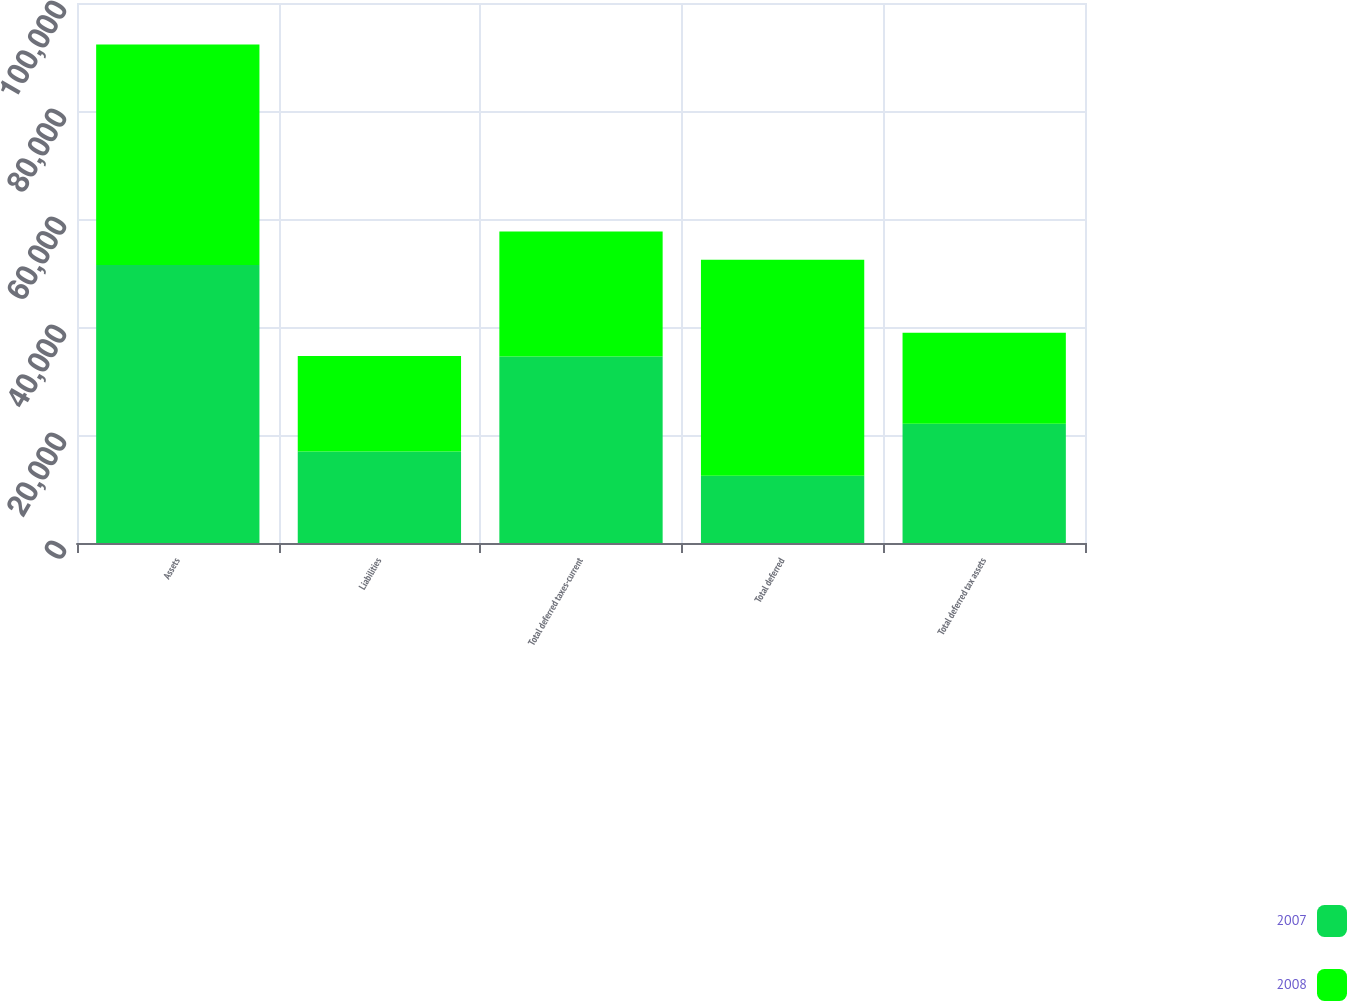Convert chart to OTSL. <chart><loc_0><loc_0><loc_500><loc_500><stacked_bar_chart><ecel><fcel>Assets<fcel>Liabilities<fcel>Total deferred taxes-current<fcel>Total deferred<fcel>Total deferred tax assets<nl><fcel>2007<fcel>51460<fcel>16938<fcel>34522<fcel>12439<fcel>22083<nl><fcel>2008<fcel>40835<fcel>17682<fcel>23153<fcel>40022<fcel>16869<nl></chart> 